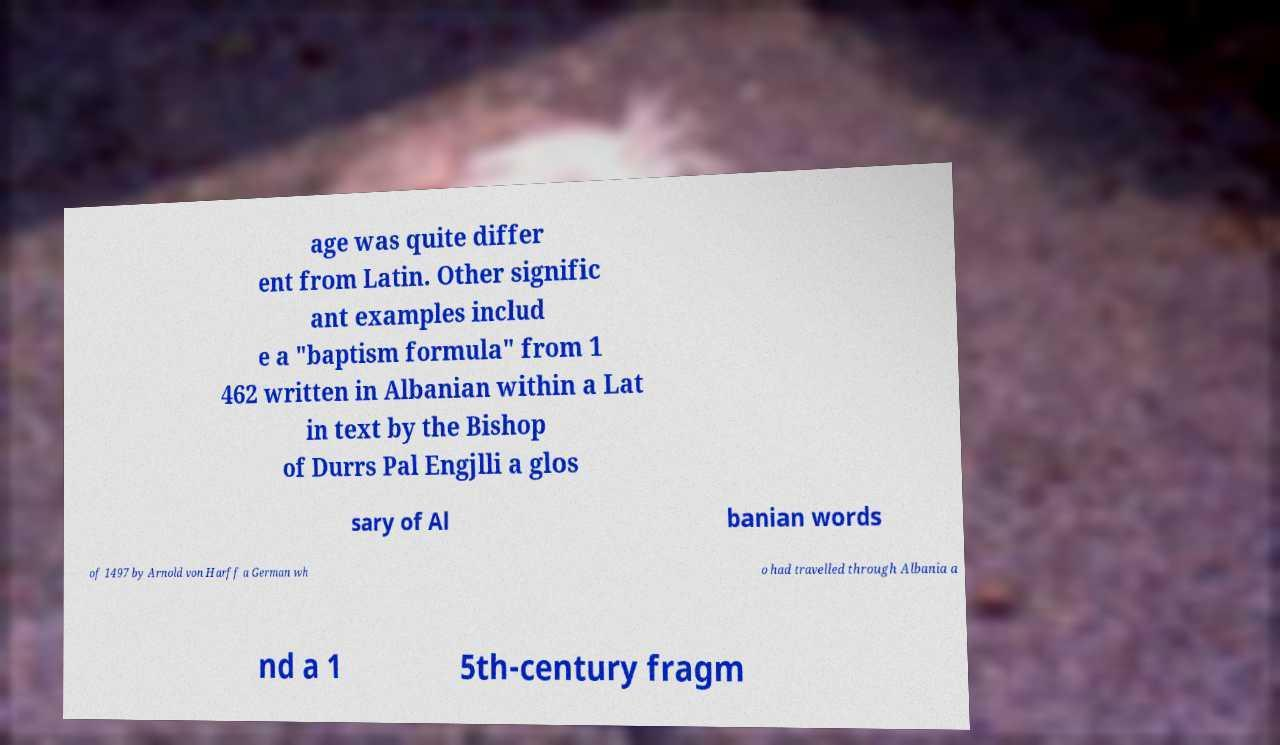For documentation purposes, I need the text within this image transcribed. Could you provide that? age was quite differ ent from Latin. Other signific ant examples includ e a "baptism formula" from 1 462 written in Albanian within a Lat in text by the Bishop of Durrs Pal Engjlli a glos sary of Al banian words of 1497 by Arnold von Harff a German wh o had travelled through Albania a nd a 1 5th-century fragm 